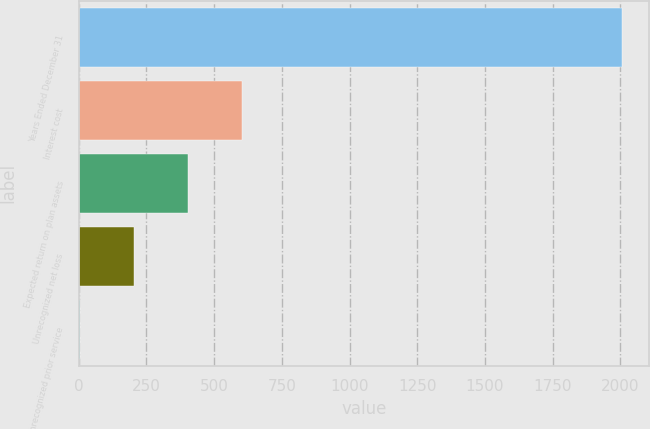<chart> <loc_0><loc_0><loc_500><loc_500><bar_chart><fcel>Years Ended December 31<fcel>Interest cost<fcel>Expected return on plan assets<fcel>Unrecognized net loss<fcel>Unrecognized prior service<nl><fcel>2005<fcel>603.6<fcel>403.4<fcel>203.2<fcel>3<nl></chart> 